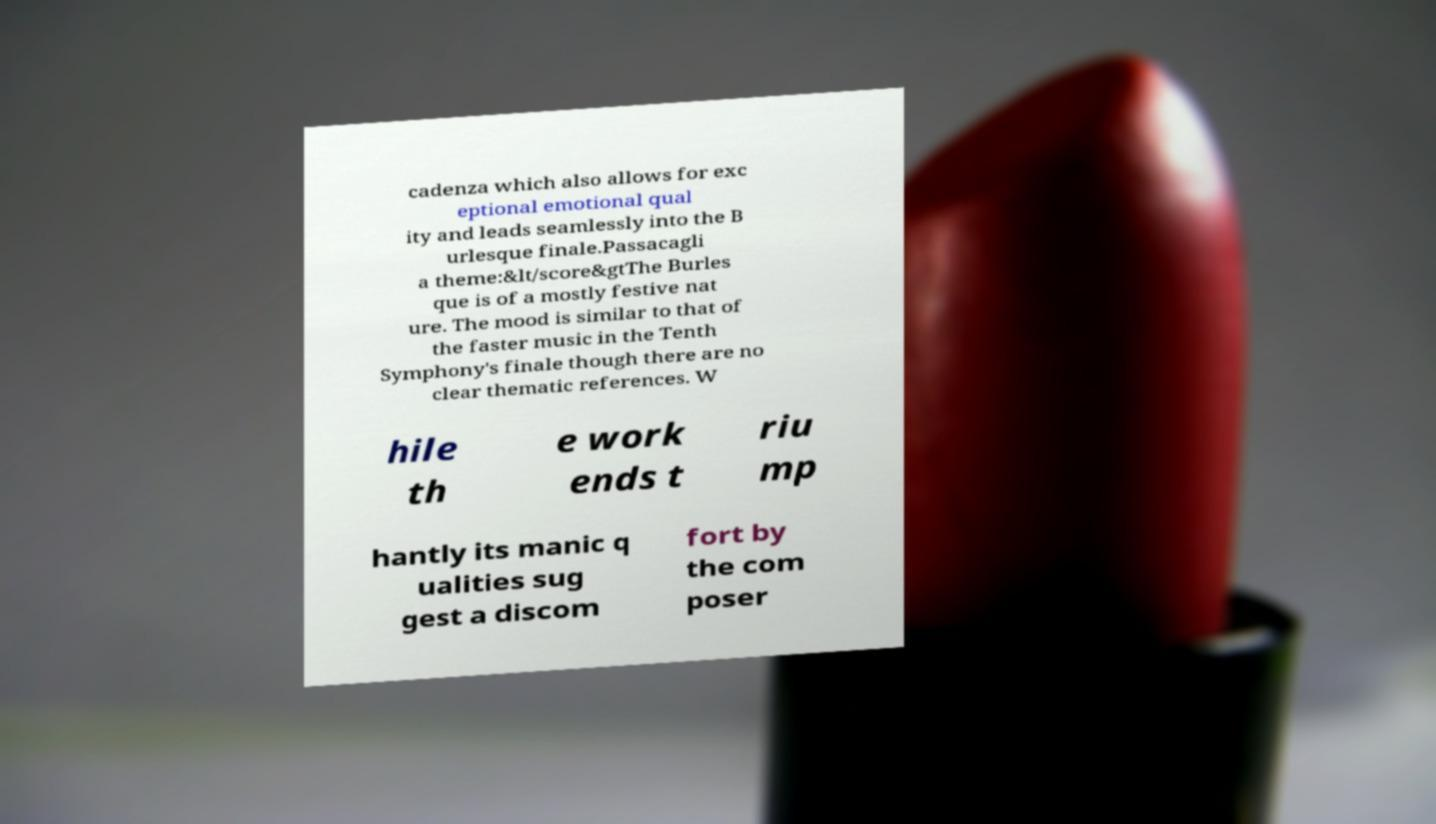Please read and relay the text visible in this image. What does it say? cadenza which also allows for exc eptional emotional qual ity and leads seamlessly into the B urlesque finale.Passacagli a theme:&lt/score&gtThe Burles que is of a mostly festive nat ure. The mood is similar to that of the faster music in the Tenth Symphony's finale though there are no clear thematic references. W hile th e work ends t riu mp hantly its manic q ualities sug gest a discom fort by the com poser 